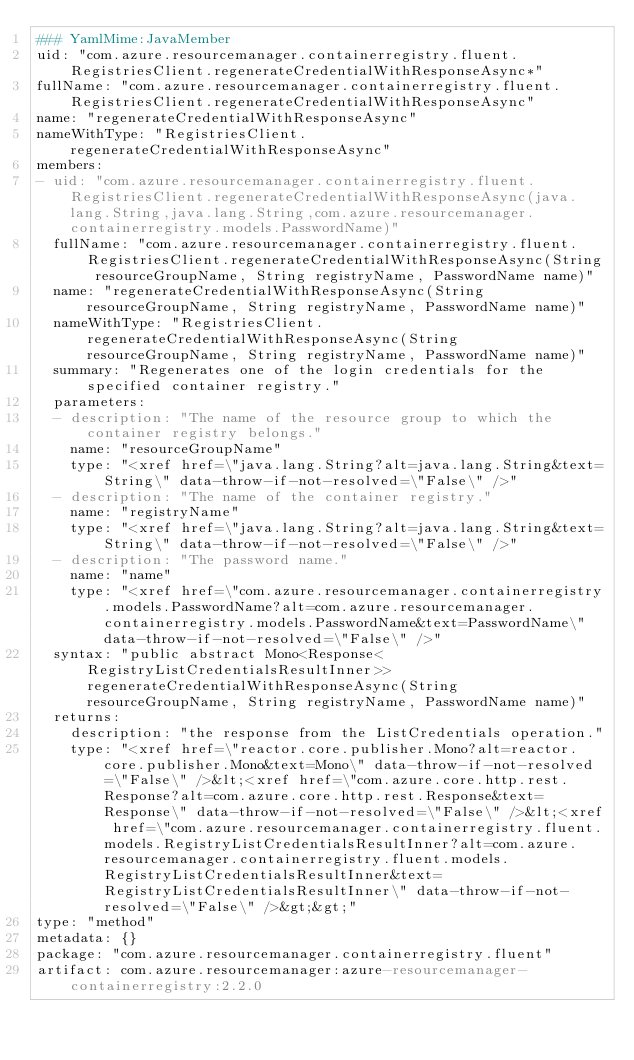Convert code to text. <code><loc_0><loc_0><loc_500><loc_500><_YAML_>### YamlMime:JavaMember
uid: "com.azure.resourcemanager.containerregistry.fluent.RegistriesClient.regenerateCredentialWithResponseAsync*"
fullName: "com.azure.resourcemanager.containerregistry.fluent.RegistriesClient.regenerateCredentialWithResponseAsync"
name: "regenerateCredentialWithResponseAsync"
nameWithType: "RegistriesClient.regenerateCredentialWithResponseAsync"
members:
- uid: "com.azure.resourcemanager.containerregistry.fluent.RegistriesClient.regenerateCredentialWithResponseAsync(java.lang.String,java.lang.String,com.azure.resourcemanager.containerregistry.models.PasswordName)"
  fullName: "com.azure.resourcemanager.containerregistry.fluent.RegistriesClient.regenerateCredentialWithResponseAsync(String resourceGroupName, String registryName, PasswordName name)"
  name: "regenerateCredentialWithResponseAsync(String resourceGroupName, String registryName, PasswordName name)"
  nameWithType: "RegistriesClient.regenerateCredentialWithResponseAsync(String resourceGroupName, String registryName, PasswordName name)"
  summary: "Regenerates one of the login credentials for the specified container registry."
  parameters:
  - description: "The name of the resource group to which the container registry belongs."
    name: "resourceGroupName"
    type: "<xref href=\"java.lang.String?alt=java.lang.String&text=String\" data-throw-if-not-resolved=\"False\" />"
  - description: "The name of the container registry."
    name: "registryName"
    type: "<xref href=\"java.lang.String?alt=java.lang.String&text=String\" data-throw-if-not-resolved=\"False\" />"
  - description: "The password name."
    name: "name"
    type: "<xref href=\"com.azure.resourcemanager.containerregistry.models.PasswordName?alt=com.azure.resourcemanager.containerregistry.models.PasswordName&text=PasswordName\" data-throw-if-not-resolved=\"False\" />"
  syntax: "public abstract Mono<Response<RegistryListCredentialsResultInner>> regenerateCredentialWithResponseAsync(String resourceGroupName, String registryName, PasswordName name)"
  returns:
    description: "the response from the ListCredentials operation."
    type: "<xref href=\"reactor.core.publisher.Mono?alt=reactor.core.publisher.Mono&text=Mono\" data-throw-if-not-resolved=\"False\" />&lt;<xref href=\"com.azure.core.http.rest.Response?alt=com.azure.core.http.rest.Response&text=Response\" data-throw-if-not-resolved=\"False\" />&lt;<xref href=\"com.azure.resourcemanager.containerregistry.fluent.models.RegistryListCredentialsResultInner?alt=com.azure.resourcemanager.containerregistry.fluent.models.RegistryListCredentialsResultInner&text=RegistryListCredentialsResultInner\" data-throw-if-not-resolved=\"False\" />&gt;&gt;"
type: "method"
metadata: {}
package: "com.azure.resourcemanager.containerregistry.fluent"
artifact: com.azure.resourcemanager:azure-resourcemanager-containerregistry:2.2.0
</code> 